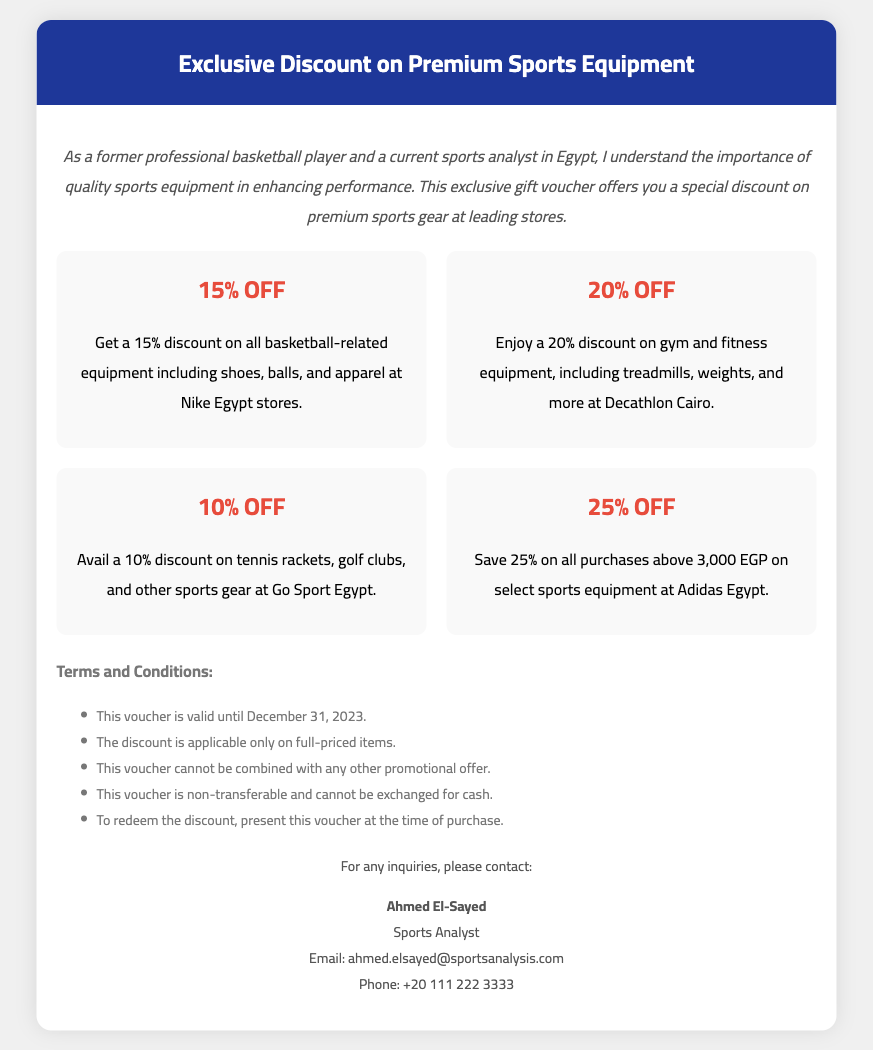What is the discount on basketball-related equipment? The document states that there is a 15% discount on basketball-related equipment.
Answer: 15% OFF What is the expiration date of the voucher? The document mentions that this voucher is valid until December 31, 2023.
Answer: December 31, 2023 Which store offers a 20% discount on gym equipment? The 20% discount on gym and fitness equipment is offered at Decathlon Cairo.
Answer: Decathlon Cairo How much do you save if you purchase over 3,000 EGP at Adidas Egypt? The document specifies a 25% discount for purchases above 3,000 EGP at Adidas Egypt.
Answer: 25% OFF Is this voucher transferable? According to the terms, the voucher is non-transferable and cannot be exchanged for cash.
Answer: Non-transferable What is the contact person's name for inquiries? The document lists Ahmed El-Sayed as the contact person for inquiries.
Answer: Ahmed El-Sayed What types of products are included in the 10% discount at Go Sport Egypt? The document states that the 10% discount applies to tennis rackets, golf clubs, and other sports gear.
Answer: Tennis rackets, golf clubs Can this voucher be combined with other promotional offers? The terms state that this voucher cannot be combined with any other promotional offer.
Answer: No What is the contact email address provided in the document? The document includes the email address ahmed.elsayed@sportsanalysis.com for contact.
Answer: ahmed.elsayed@sportsanalysis.com 